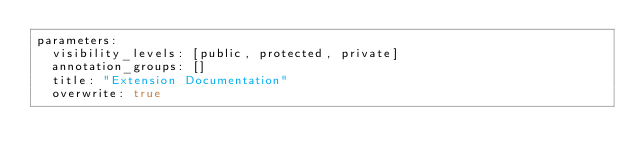<code> <loc_0><loc_0><loc_500><loc_500><_YAML_>parameters:
  visibility_levels: [public, protected, private]
  annotation_groups: []
  title: "Extension Documentation"
  overwrite: true
</code> 